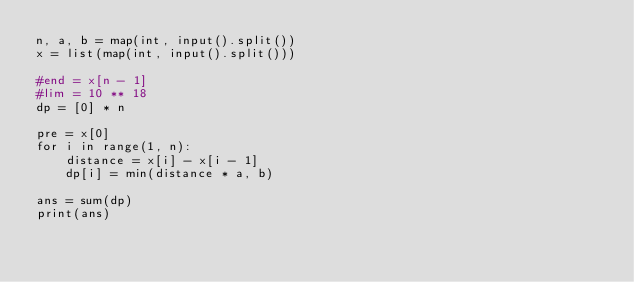<code> <loc_0><loc_0><loc_500><loc_500><_Python_>n, a, b = map(int, input().split())
x = list(map(int, input().split()))

#end = x[n - 1]
#lim = 10 ** 18
dp = [0] * n

pre = x[0]
for i in range(1, n):
    distance = x[i] - x[i - 1]
    dp[i] = min(distance * a, b)

ans = sum(dp)
print(ans)</code> 